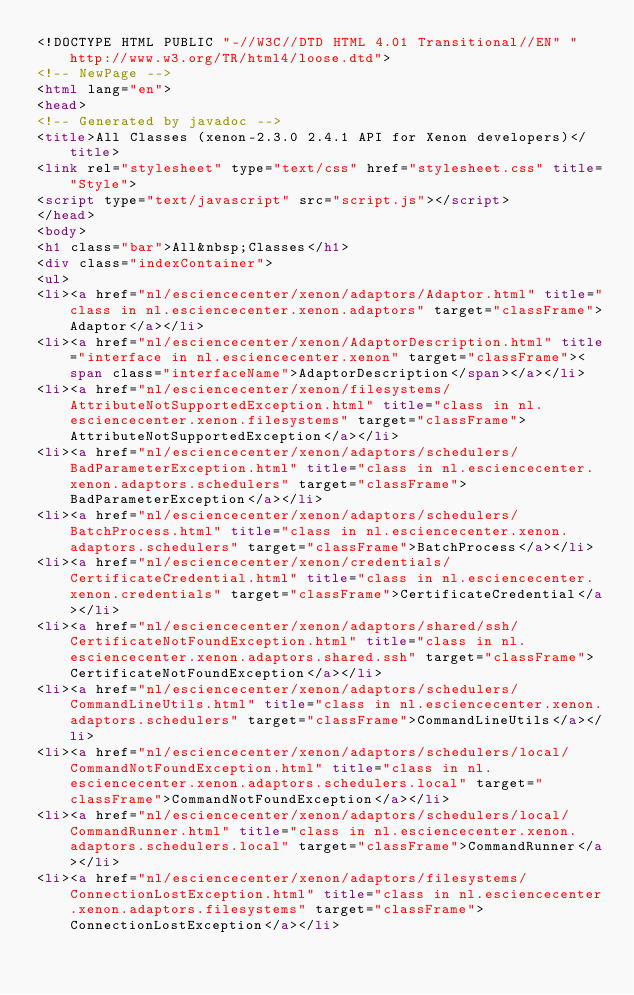Convert code to text. <code><loc_0><loc_0><loc_500><loc_500><_HTML_><!DOCTYPE HTML PUBLIC "-//W3C//DTD HTML 4.01 Transitional//EN" "http://www.w3.org/TR/html4/loose.dtd">
<!-- NewPage -->
<html lang="en">
<head>
<!-- Generated by javadoc -->
<title>All Classes (xenon-2.3.0 2.4.1 API for Xenon developers)</title>
<link rel="stylesheet" type="text/css" href="stylesheet.css" title="Style">
<script type="text/javascript" src="script.js"></script>
</head>
<body>
<h1 class="bar">All&nbsp;Classes</h1>
<div class="indexContainer">
<ul>
<li><a href="nl/esciencecenter/xenon/adaptors/Adaptor.html" title="class in nl.esciencecenter.xenon.adaptors" target="classFrame">Adaptor</a></li>
<li><a href="nl/esciencecenter/xenon/AdaptorDescription.html" title="interface in nl.esciencecenter.xenon" target="classFrame"><span class="interfaceName">AdaptorDescription</span></a></li>
<li><a href="nl/esciencecenter/xenon/filesystems/AttributeNotSupportedException.html" title="class in nl.esciencecenter.xenon.filesystems" target="classFrame">AttributeNotSupportedException</a></li>
<li><a href="nl/esciencecenter/xenon/adaptors/schedulers/BadParameterException.html" title="class in nl.esciencecenter.xenon.adaptors.schedulers" target="classFrame">BadParameterException</a></li>
<li><a href="nl/esciencecenter/xenon/adaptors/schedulers/BatchProcess.html" title="class in nl.esciencecenter.xenon.adaptors.schedulers" target="classFrame">BatchProcess</a></li>
<li><a href="nl/esciencecenter/xenon/credentials/CertificateCredential.html" title="class in nl.esciencecenter.xenon.credentials" target="classFrame">CertificateCredential</a></li>
<li><a href="nl/esciencecenter/xenon/adaptors/shared/ssh/CertificateNotFoundException.html" title="class in nl.esciencecenter.xenon.adaptors.shared.ssh" target="classFrame">CertificateNotFoundException</a></li>
<li><a href="nl/esciencecenter/xenon/adaptors/schedulers/CommandLineUtils.html" title="class in nl.esciencecenter.xenon.adaptors.schedulers" target="classFrame">CommandLineUtils</a></li>
<li><a href="nl/esciencecenter/xenon/adaptors/schedulers/local/CommandNotFoundException.html" title="class in nl.esciencecenter.xenon.adaptors.schedulers.local" target="classFrame">CommandNotFoundException</a></li>
<li><a href="nl/esciencecenter/xenon/adaptors/schedulers/local/CommandRunner.html" title="class in nl.esciencecenter.xenon.adaptors.schedulers.local" target="classFrame">CommandRunner</a></li>
<li><a href="nl/esciencecenter/xenon/adaptors/filesystems/ConnectionLostException.html" title="class in nl.esciencecenter.xenon.adaptors.filesystems" target="classFrame">ConnectionLostException</a></li></code> 